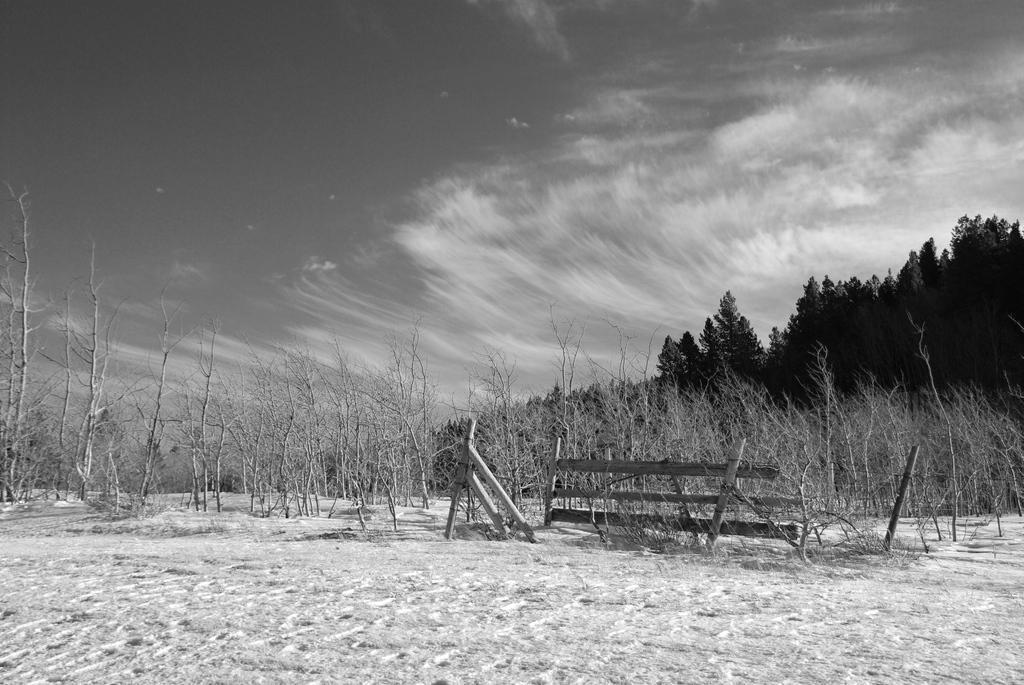Describe this image in one or two sentences. In this picture in the center there are dry plants. In the background there are trees and the sky is cloudy. 